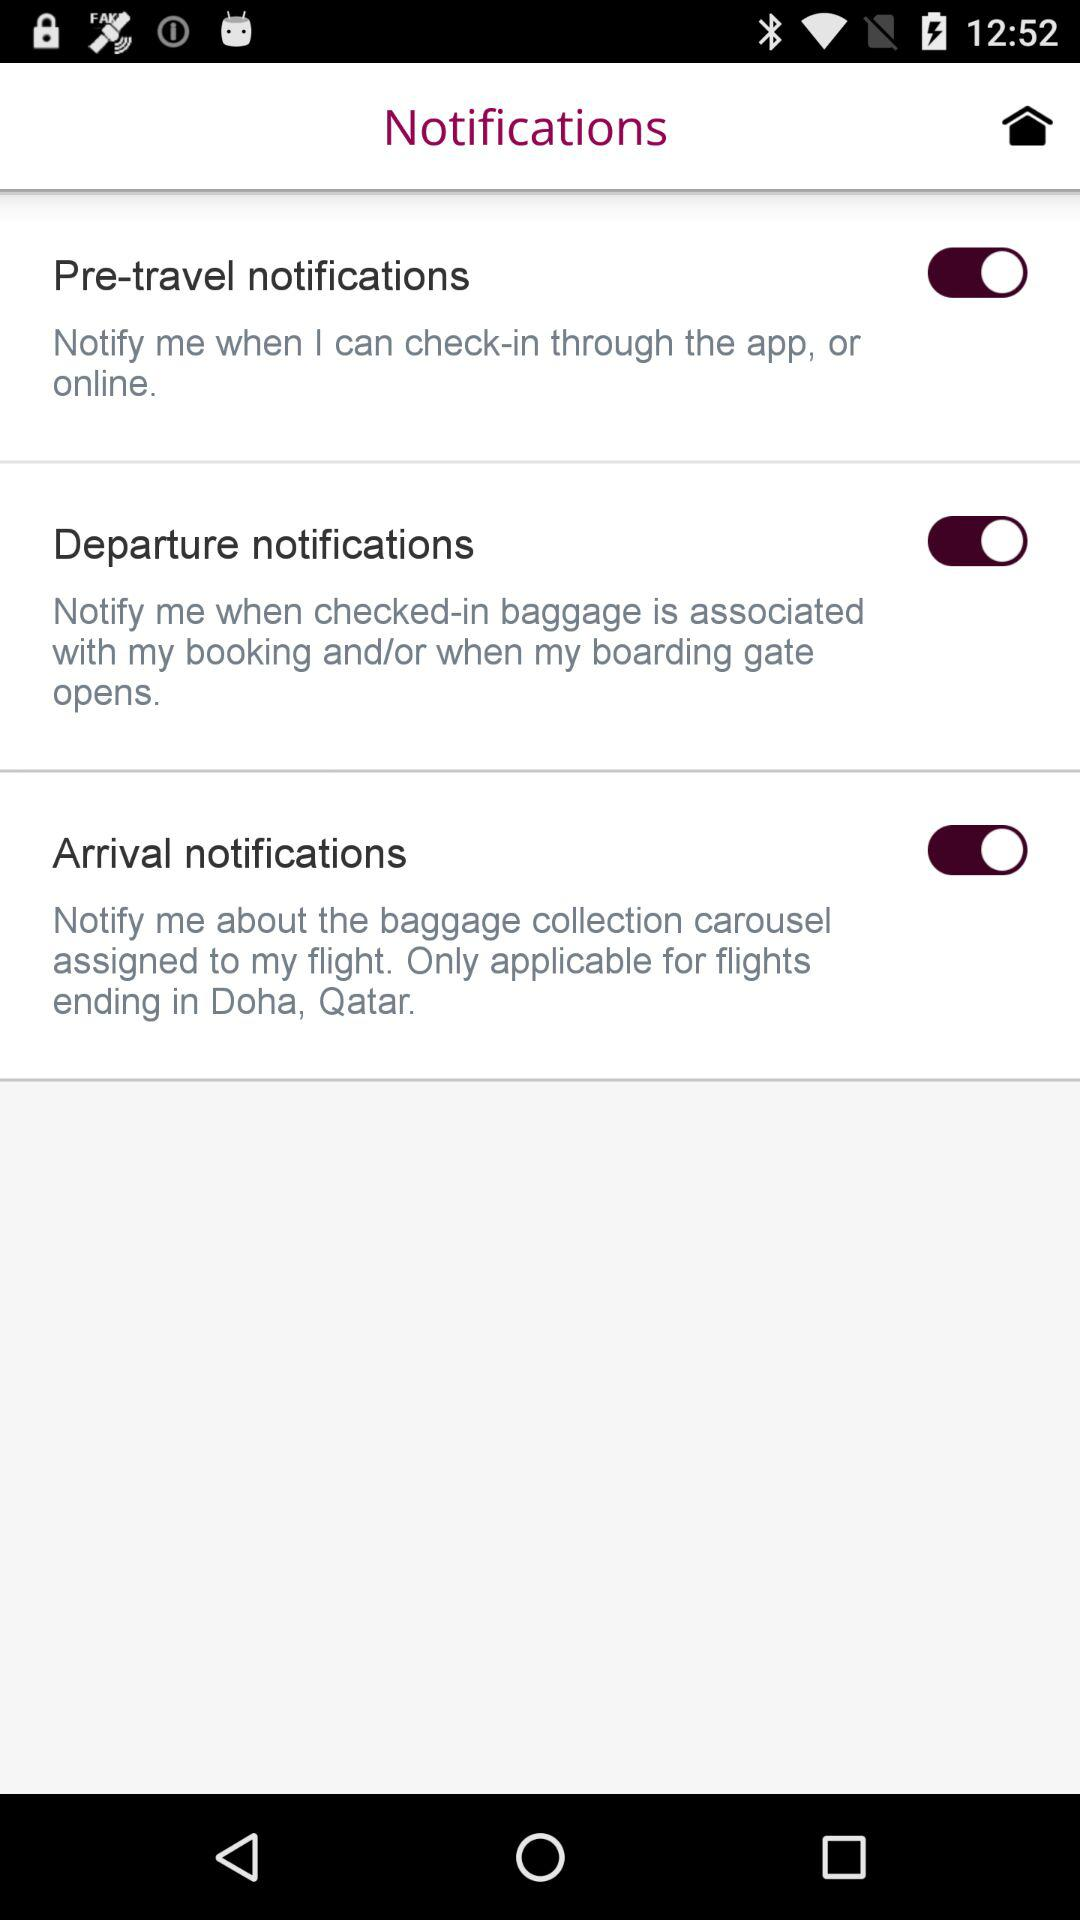How many notifications are there in total?
Answer the question using a single word or phrase. 3 